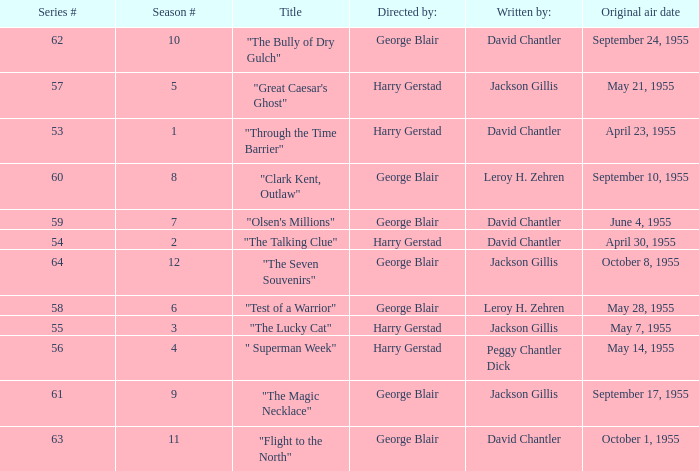Which Season originally aired on September 17, 1955 9.0. 